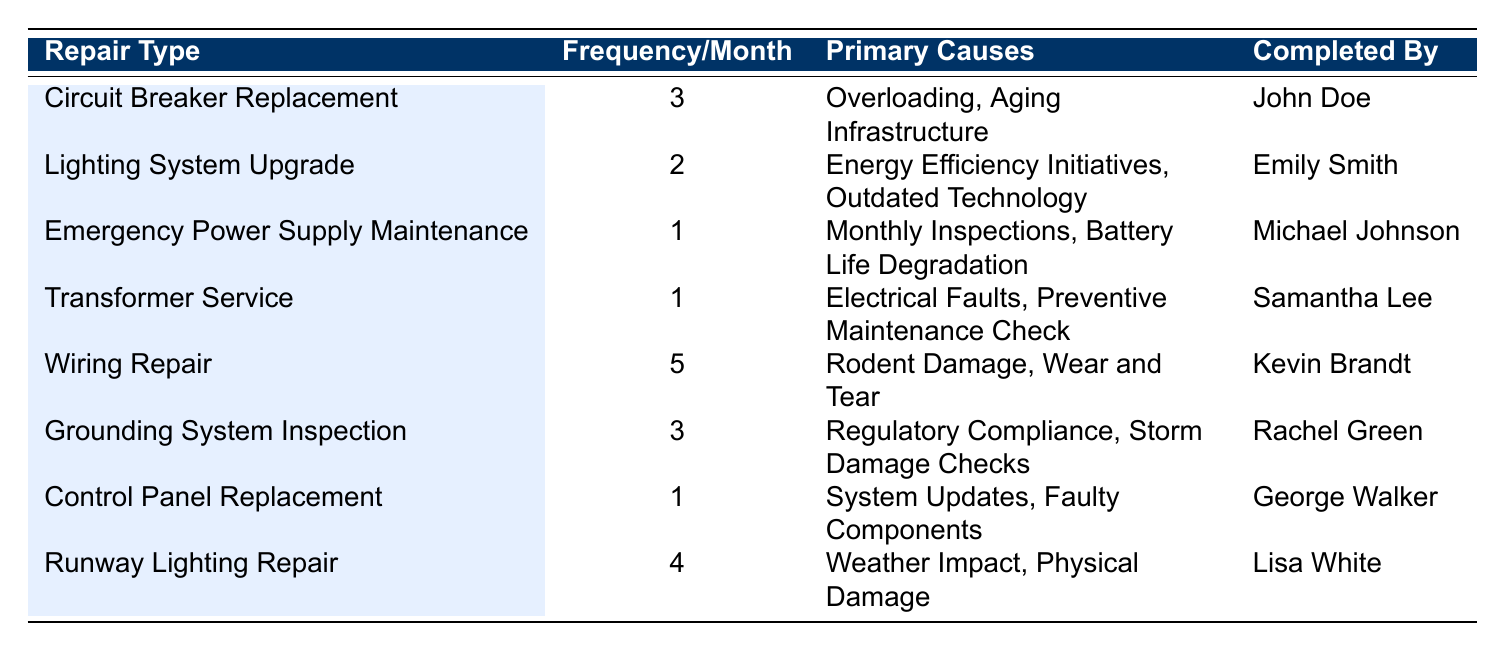What is the most frequently performed electrical repair in the airport facilities? The most frequently performed repair can be found by identifying the repair type with the highest frequency in the table. According to the data, "Wiring Repair" has the highest frequency of 5 per month.
Answer: Wiring Repair How many repairs are related to weather impacts? In the table, we can see that "Runway Lighting Repair" is the only repair type related to weather, with a primary cause of "Weather Impact." Thus, there is 1 repair associated with weather impacts.
Answer: 1 What is the total frequency of electrical repairs that have "Aging Infrastructure" as a primary cause? The relevant repairs that list "Aging Infrastructure" as a cause are "Circuit Breaker Replacement." Its frequency is 3 per month. There is only this repair associated, leading to a total frequency of 3.
Answer: 3 Is it true that all repairs in the table are completed by different individuals? Looking through the "Completed By" column, all repair types are assigned to different individuals without any overlaps. Thus, the statement is true.
Answer: Yes What is the average frequency of electrical repairs performed per month? To find the average frequency, we sum up the frequencies of all repair types: (3 + 2 + 1 + 1 + 5 + 3 + 1 + 4) = 20. Then, we divide by the total number of repairs (8). The average frequency is 20/8 = 2.5.
Answer: 2.5 How many repair types have a frequency of less than 2? In the table, the repairs with frequencies less than 2 are "Emergency Power Supply Maintenance," "Transformer Service," and "Control Panel Replacement," totaling 3 repair types.
Answer: 3 What is the difference in frequency between the most and least frequently performed repairs? The most frequently performed repair is "Wiring Repair" with a frequency of 5, and the least frequent repairs (which are multiple) like "Emergency Power Supply Maintenance," "Transformer Service," and "Control Panel Replacement" each have a frequency of 1. Therefore, the difference is 5 - 1 = 4.
Answer: 4 Which repair type has the least frequency but specifically involves regulatory compliance? The only repair type that involves "Regulatory Compliance" as a primary cause is "Grounding System Inspection," with a frequency of 3 per month. It is not the least frequent, but it is the only relevant repair type.
Answer: Grounding System Inspection 